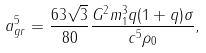Convert formula to latex. <formula><loc_0><loc_0><loc_500><loc_500>a _ { g r } ^ { 5 } = \frac { 6 3 \sqrt { 3 } } { 8 0 } \frac { G ^ { 2 } m _ { 1 } ^ { 3 } q ( 1 + q ) \sigma } { c ^ { 5 } \rho _ { 0 } } ,</formula> 